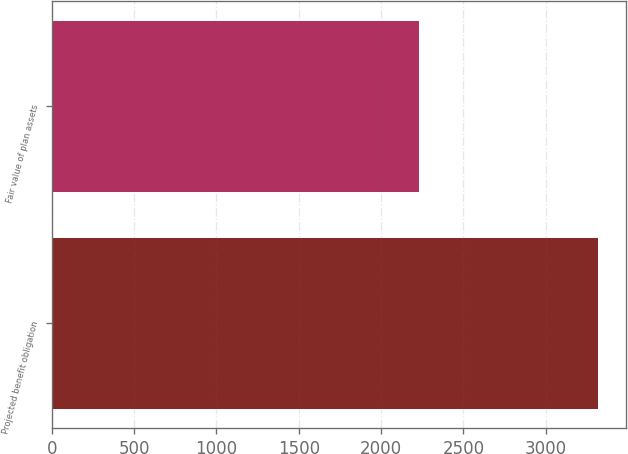Convert chart to OTSL. <chart><loc_0><loc_0><loc_500><loc_500><bar_chart><fcel>Projected benefit obligation<fcel>Fair value of plan assets<nl><fcel>3320<fcel>2228<nl></chart> 